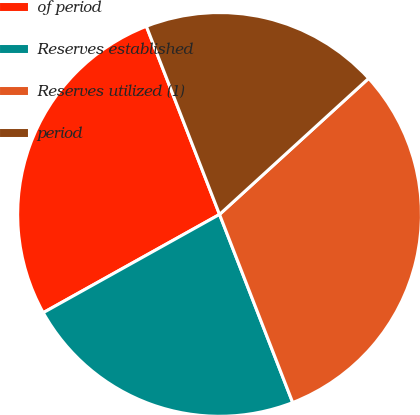<chart> <loc_0><loc_0><loc_500><loc_500><pie_chart><fcel>of period<fcel>Reserves established<fcel>Reserves utilized (1)<fcel>period<nl><fcel>27.19%<fcel>22.81%<fcel>30.87%<fcel>19.13%<nl></chart> 